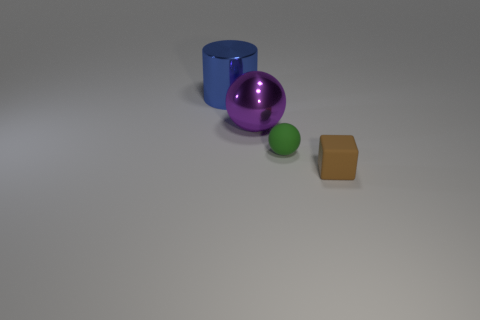Subtract all cylinders. How many objects are left? 3 Subtract all purple balls. How many balls are left? 1 Add 3 matte objects. How many objects exist? 7 Subtract 0 yellow balls. How many objects are left? 4 Subtract 1 cylinders. How many cylinders are left? 0 Subtract all cyan blocks. Subtract all yellow cylinders. How many blocks are left? 1 Subtract all gray cylinders. How many yellow cubes are left? 0 Subtract all green spheres. Subtract all brown matte blocks. How many objects are left? 2 Add 1 shiny things. How many shiny things are left? 3 Add 1 matte blocks. How many matte blocks exist? 2 